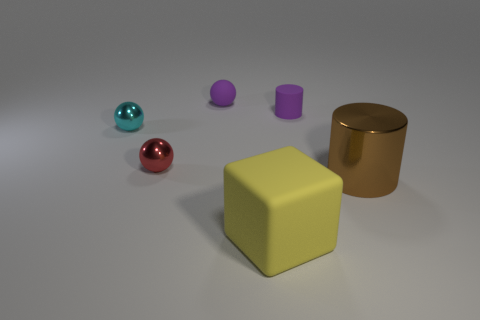Is there any other thing that is the same size as the brown cylinder?
Keep it short and to the point. Yes. Are there any large brown shiny things?
Your answer should be very brief. Yes. The purple thing that is to the right of the small thing behind the matte thing right of the yellow rubber cube is made of what material?
Ensure brevity in your answer.  Rubber. There is a big brown object; does it have the same shape as the purple object right of the rubber block?
Provide a short and direct response. Yes. How many tiny objects are the same shape as the large rubber object?
Your answer should be compact. 0. The cyan object has what shape?
Provide a succinct answer. Sphere. There is a metal object that is on the right side of the small matte thing behind the small purple rubber cylinder; what size is it?
Your answer should be compact. Large. How many things are either small cyan blocks or red shiny spheres?
Give a very brief answer. 1. Does the cyan shiny thing have the same shape as the red shiny object?
Provide a succinct answer. Yes. Is there a large purple block that has the same material as the small cyan sphere?
Provide a succinct answer. No. 